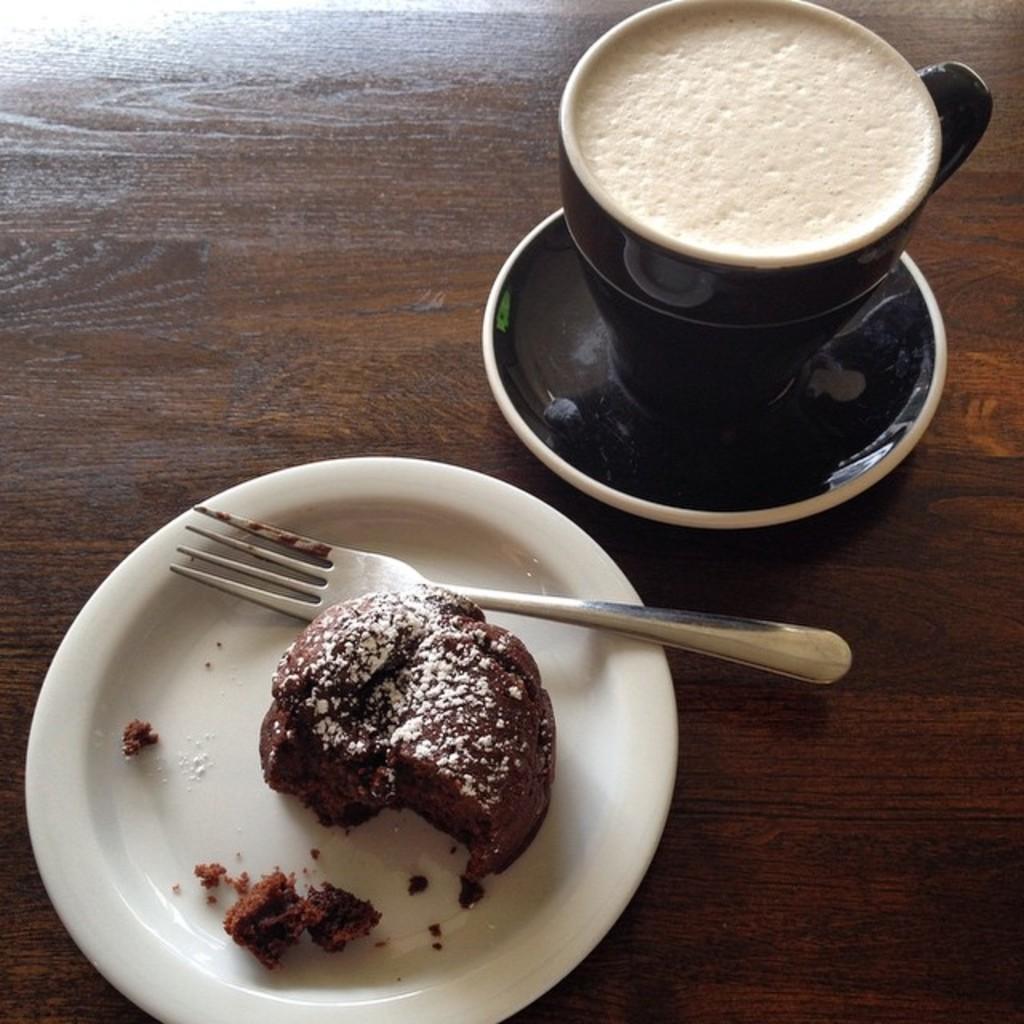How would you summarize this image in a sentence or two? In this image on the wooden surface, we can see a plate in which we can see a piece of cake and fork and beside that we can see a saucer in which we can see a cup of tea. 